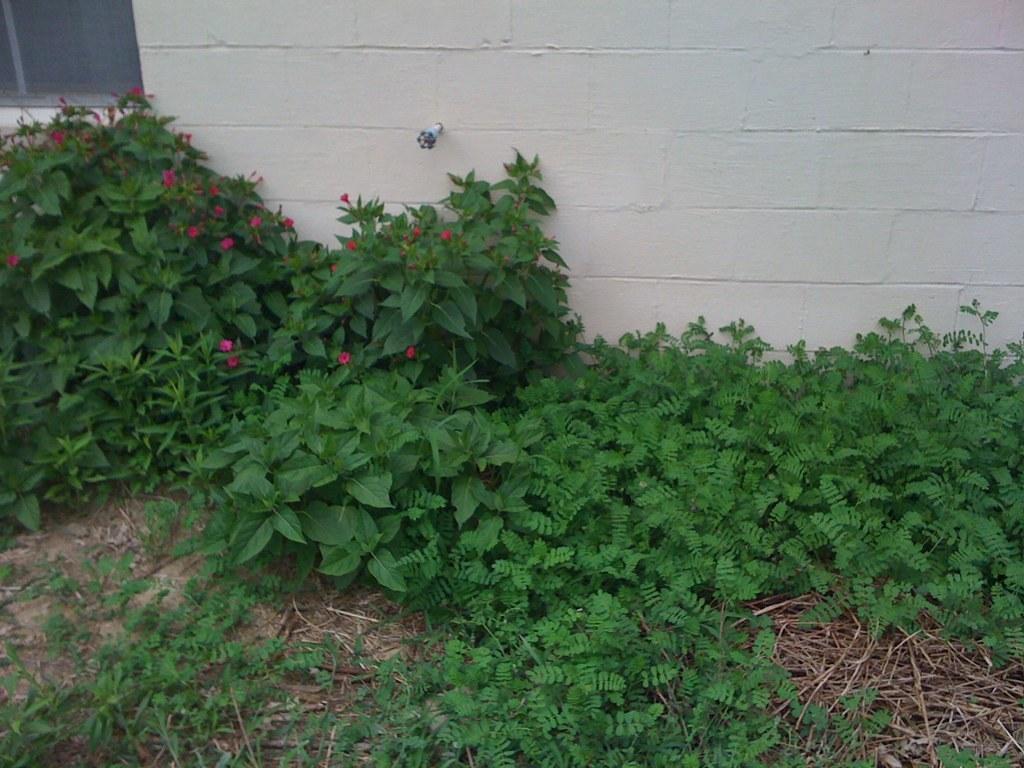In one or two sentences, can you explain what this image depicts? In this image there are plants and we can see shrubs. There are twigs and we can see flowers. In the background there is a wall. 